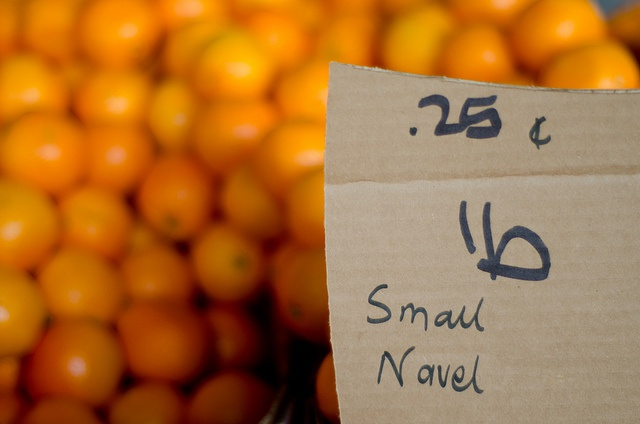Describe the objects in this image and their specific colors. I can see orange in orange, red, and maroon tones, orange in orange, maroon, and brown tones, orange in orange, red, and brown tones, orange in orange and red tones, and orange in orange and red tones in this image. 